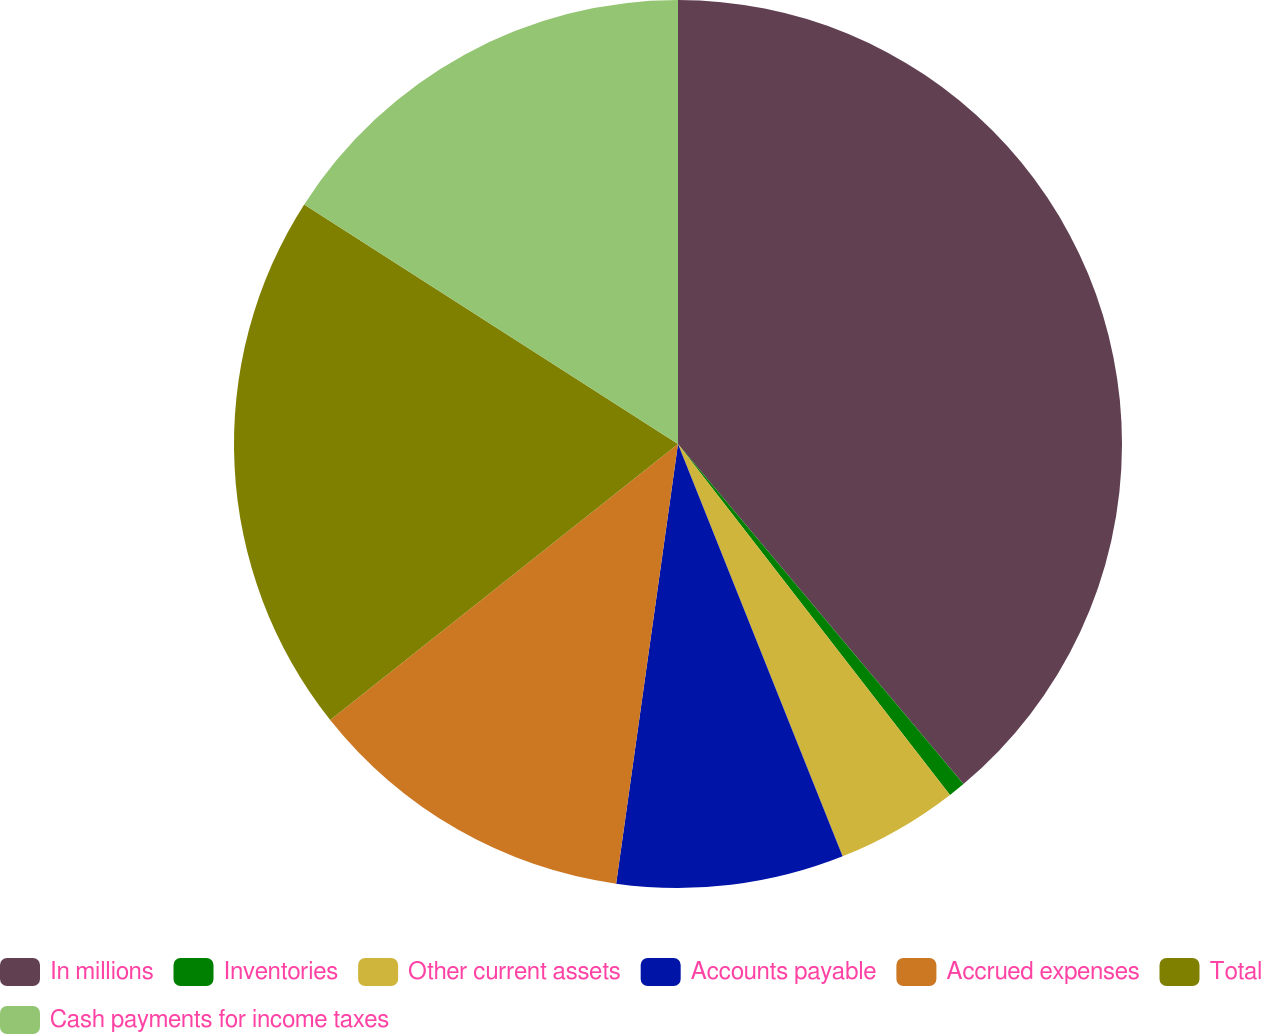Convert chart. <chart><loc_0><loc_0><loc_500><loc_500><pie_chart><fcel>In millions<fcel>Inventories<fcel>Other current assets<fcel>Accounts payable<fcel>Accrued expenses<fcel>Total<fcel>Cash payments for income taxes<nl><fcel>38.89%<fcel>0.62%<fcel>4.45%<fcel>8.27%<fcel>12.1%<fcel>19.75%<fcel>15.93%<nl></chart> 